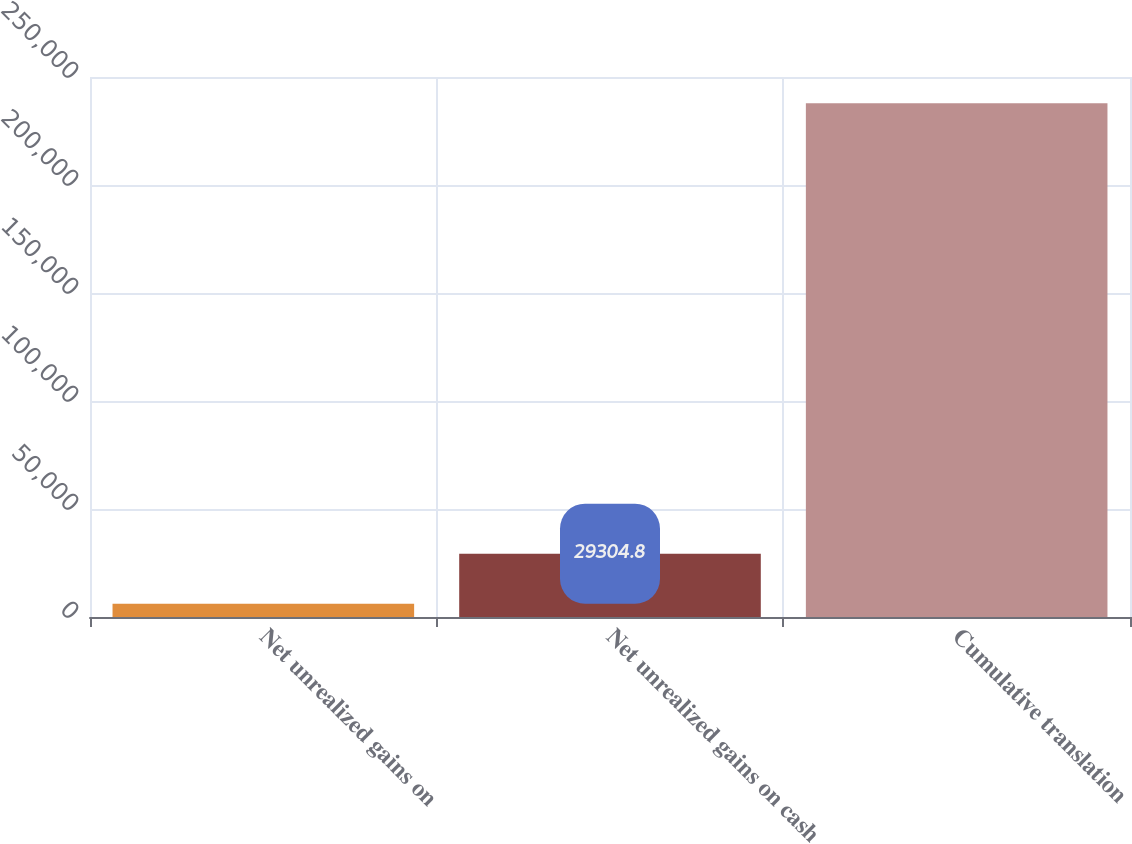Convert chart to OTSL. <chart><loc_0><loc_0><loc_500><loc_500><bar_chart><fcel>Net unrealized gains on<fcel>Net unrealized gains on cash<fcel>Cumulative translation<nl><fcel>6139<fcel>29304.8<fcel>237797<nl></chart> 